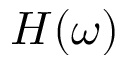Convert formula to latex. <formula><loc_0><loc_0><loc_500><loc_500>H ( \omega )</formula> 